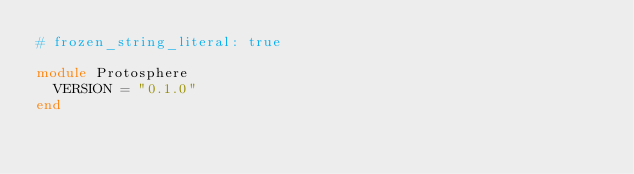Convert code to text. <code><loc_0><loc_0><loc_500><loc_500><_Ruby_># frozen_string_literal: true

module Protosphere
  VERSION = "0.1.0"
end
</code> 